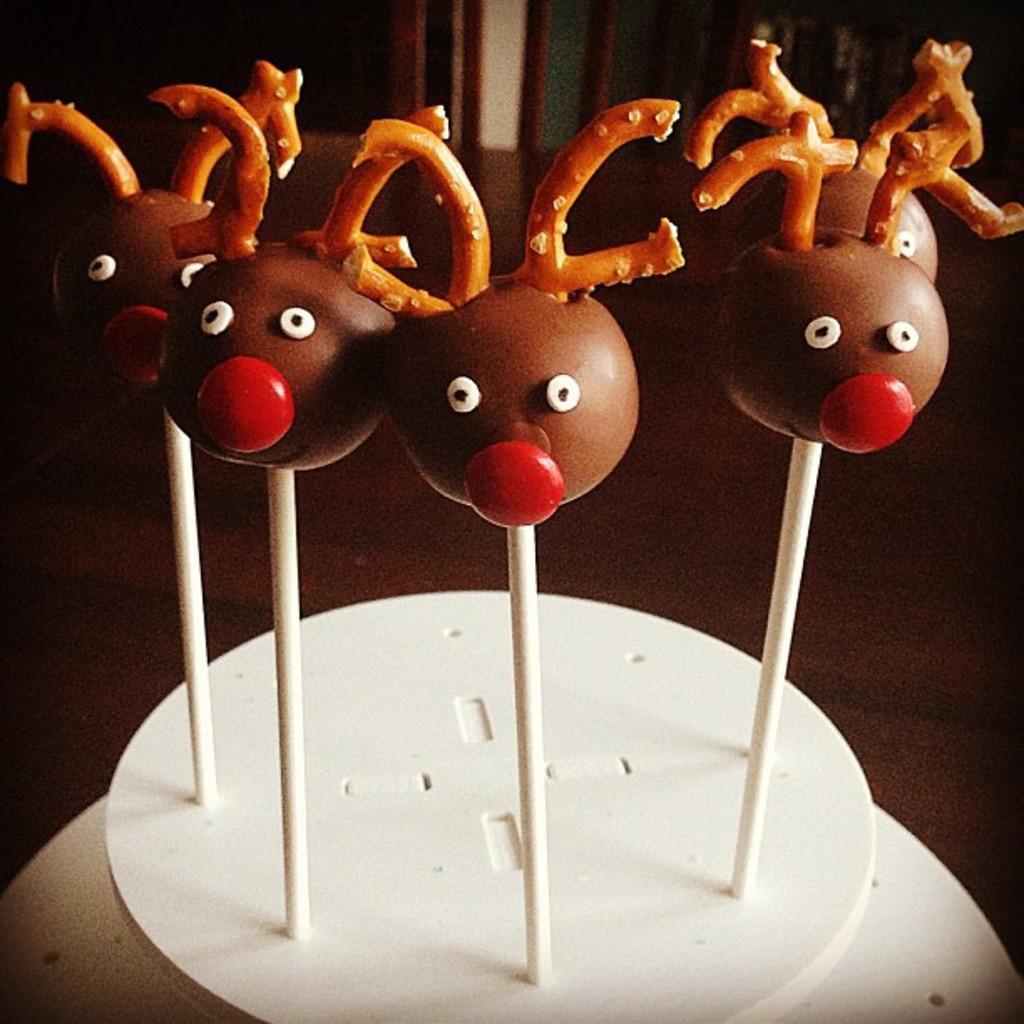In one or two sentences, can you explain what this image depicts? In this image, we can see some food items on white colored objects. We can see the ground. We can also see the background. 